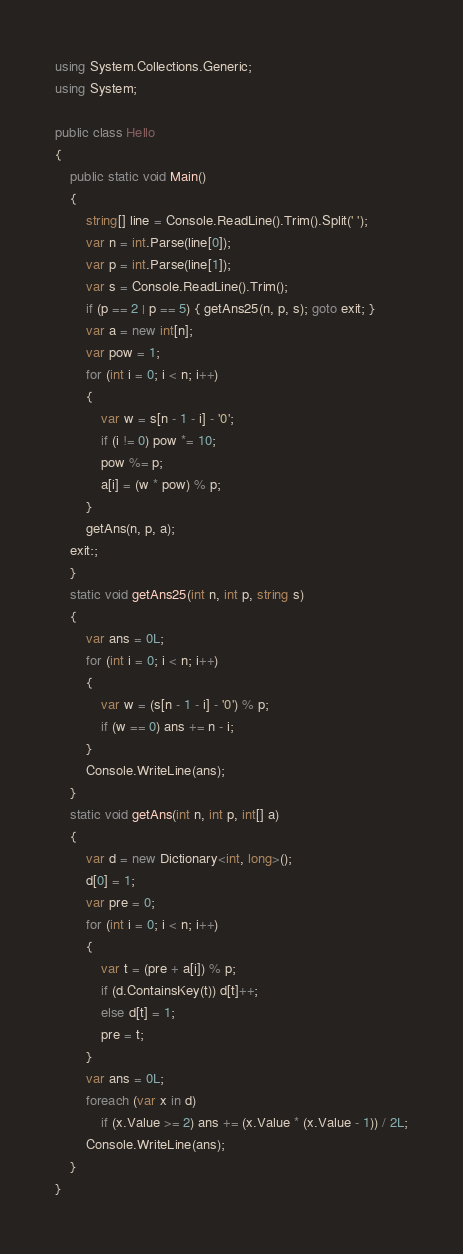Convert code to text. <code><loc_0><loc_0><loc_500><loc_500><_C#_>using System.Collections.Generic;
using System;

public class Hello
{
    public static void Main()
    {
        string[] line = Console.ReadLine().Trim().Split(' ');
        var n = int.Parse(line[0]);
        var p = int.Parse(line[1]);
        var s = Console.ReadLine().Trim();
        if (p == 2 | p == 5) { getAns25(n, p, s); goto exit; }
        var a = new int[n];
        var pow = 1;
        for (int i = 0; i < n; i++)
        {
            var w = s[n - 1 - i] - '0';
            if (i != 0) pow *= 10;
            pow %= p;
            a[i] = (w * pow) % p;
        }
        getAns(n, p, a);
    exit:;
    }
    static void getAns25(int n, int p, string s)
    {
        var ans = 0L;
        for (int i = 0; i < n; i++)
        {
            var w = (s[n - 1 - i] - '0') % p;
            if (w == 0) ans += n - i;
        }
        Console.WriteLine(ans);
    }
    static void getAns(int n, int p, int[] a)
    {
        var d = new Dictionary<int, long>();
        d[0] = 1;
        var pre = 0;
        for (int i = 0; i < n; i++)
        {
            var t = (pre + a[i]) % p;
            if (d.ContainsKey(t)) d[t]++;
            else d[t] = 1;
            pre = t;
        }
        var ans = 0L;
        foreach (var x in d)
            if (x.Value >= 2) ans += (x.Value * (x.Value - 1)) / 2L;
        Console.WriteLine(ans);
    }
}
</code> 